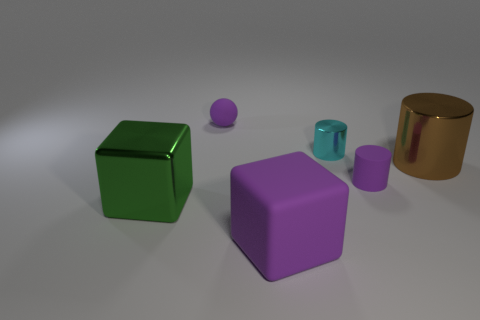Do the purple ball and the brown shiny object have the same size?
Your answer should be very brief. No. There is a metallic thing that is in front of the tiny metal object and on the left side of the big metal cylinder; what size is it?
Provide a succinct answer. Large. What number of other cyan cylinders are the same material as the cyan cylinder?
Your answer should be very brief. 0. There is a big thing that is the same color as the rubber ball; what shape is it?
Give a very brief answer. Cube. What color is the tiny metal cylinder?
Ensure brevity in your answer.  Cyan. There is a small purple matte thing right of the small purple matte sphere; does it have the same shape as the small cyan metal object?
Offer a very short reply. Yes. What number of objects are rubber balls that are behind the cyan metal thing or big brown shiny objects?
Offer a very short reply. 2. Are there any purple things that have the same shape as the big green shiny object?
Make the answer very short. Yes. There is a purple matte object that is the same size as the matte cylinder; what is its shape?
Your response must be concise. Sphere. There is a tiny rubber thing to the right of the small purple matte ball behind the small purple rubber object in front of the large brown cylinder; what is its shape?
Ensure brevity in your answer.  Cylinder. 